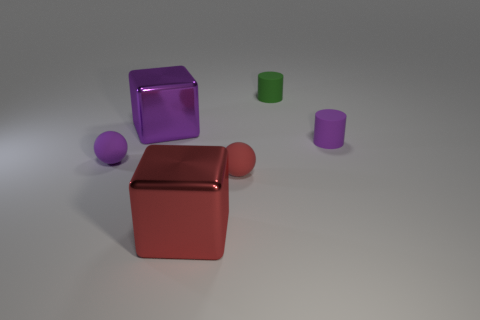How many things are the same material as the red block?
Offer a very short reply. 1. There is another tiny cylinder that is made of the same material as the tiny green cylinder; what color is it?
Keep it short and to the point. Purple. What material is the small purple object that is on the right side of the red metal object?
Your response must be concise. Rubber. Are there an equal number of purple things to the right of the large purple metal block and purple metal objects?
Provide a succinct answer. Yes. What is the color of the other metallic thing that is the same shape as the big red object?
Keep it short and to the point. Purple. Does the purple shiny block have the same size as the green matte cylinder?
Offer a very short reply. No. Are there the same number of tiny green matte things in front of the big purple metal thing and large red metal things on the left side of the red shiny cube?
Provide a succinct answer. Yes. Is there a small green rubber thing?
Keep it short and to the point. Yes. There is a red shiny object that is the same shape as the big purple shiny object; what size is it?
Give a very brief answer. Large. What is the size of the matte cylinder that is in front of the green thing?
Your response must be concise. Small. 